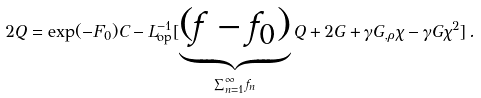Convert formula to latex. <formula><loc_0><loc_0><loc_500><loc_500>2 Q = \exp ( - F _ { 0 } ) C - L _ { \text {op} } ^ { - 1 } [ \underbrace { ( f - f _ { 0 } ) } _ { \sum _ { n = 1 } ^ { \infty } f _ { n } } Q + 2 G + \gamma G _ { , \rho } \chi - \gamma G \chi ^ { 2 } ] \, .</formula> 